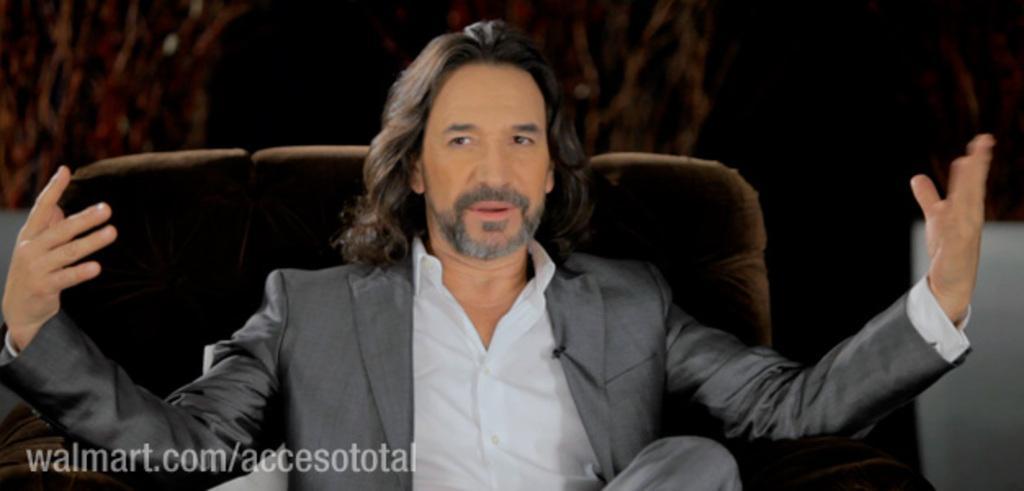Can you describe this image briefly? In the center of the image we can see a man is sitting on a couch and talking and wearing a suit. In the bottom left corner we can see a suit. In the background, the image is not clear. 